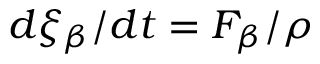Convert formula to latex. <formula><loc_0><loc_0><loc_500><loc_500>d \xi _ { \beta } / d t = F _ { \beta } / { \rho }</formula> 